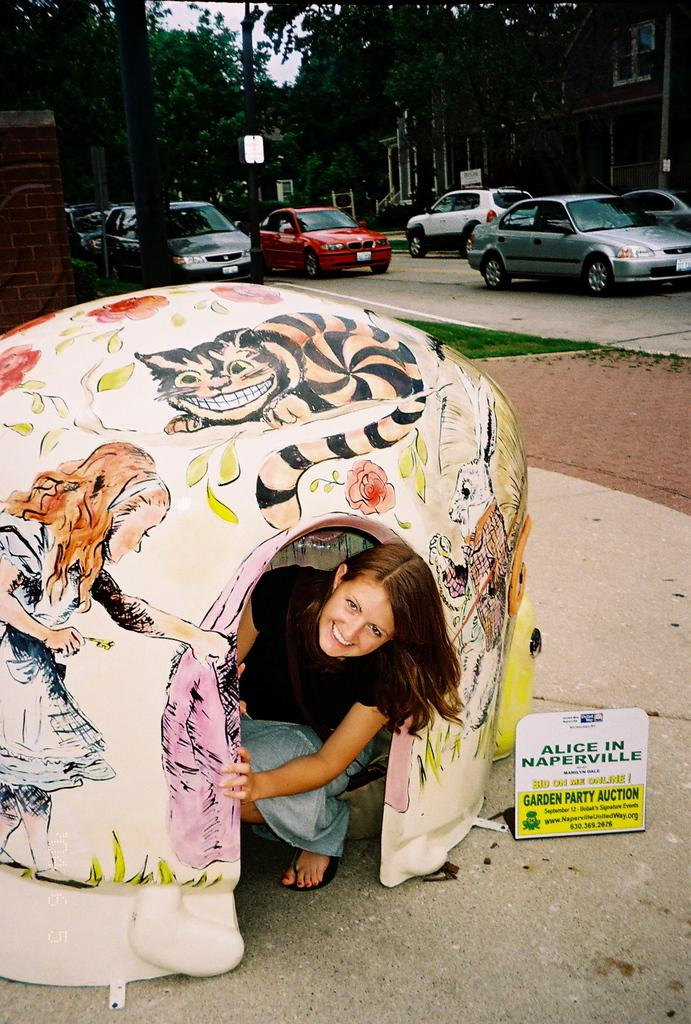What is the woman doing in the image? The woman is sitting inside the tent. What can be seen in the background of the image? There are trees, poles, vehicles, and buildings in the background of the image. What is the condition of the sky in the image? The sky is clear in the image. What type of cheese is being used to hold the tent poles together in the image? There is no cheese present in the image, and the tent poles are not held together by cheese. 